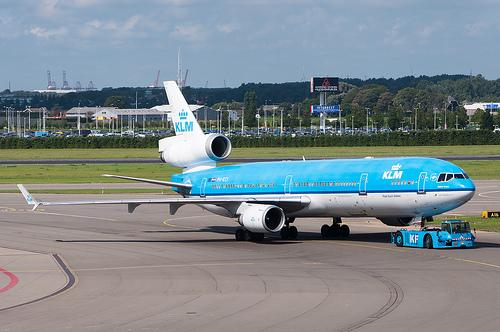What is the sentiment conveyed by the presence of clouds in the image? The sentiment conveyed by clouds in the image is neutral or calm, as they do not indicate any extreme weather or situation. Using complex reasoning, comment on the likely location of this scene based on the given information. Given the presence of a passenger airplane, parked cars, cranes in the distance, and ground equipment, this scene is likely taking place at an airport. In terms of the image quality assessment task, describe the level of detail provided by the image for the objects in the image. The image provide a good level of detail for the objects in the image by specifying their positions and sizes for a precise localization of each object. Mention the colors of the airplane in the image and where they are visible. The airplane is blue and white, with the KLM logo on its tail fin and the main body being white with blue accents. How many parked cars are shown in the image? There is a large group of parked cars, but the exact number cannot be determined from the given information. 